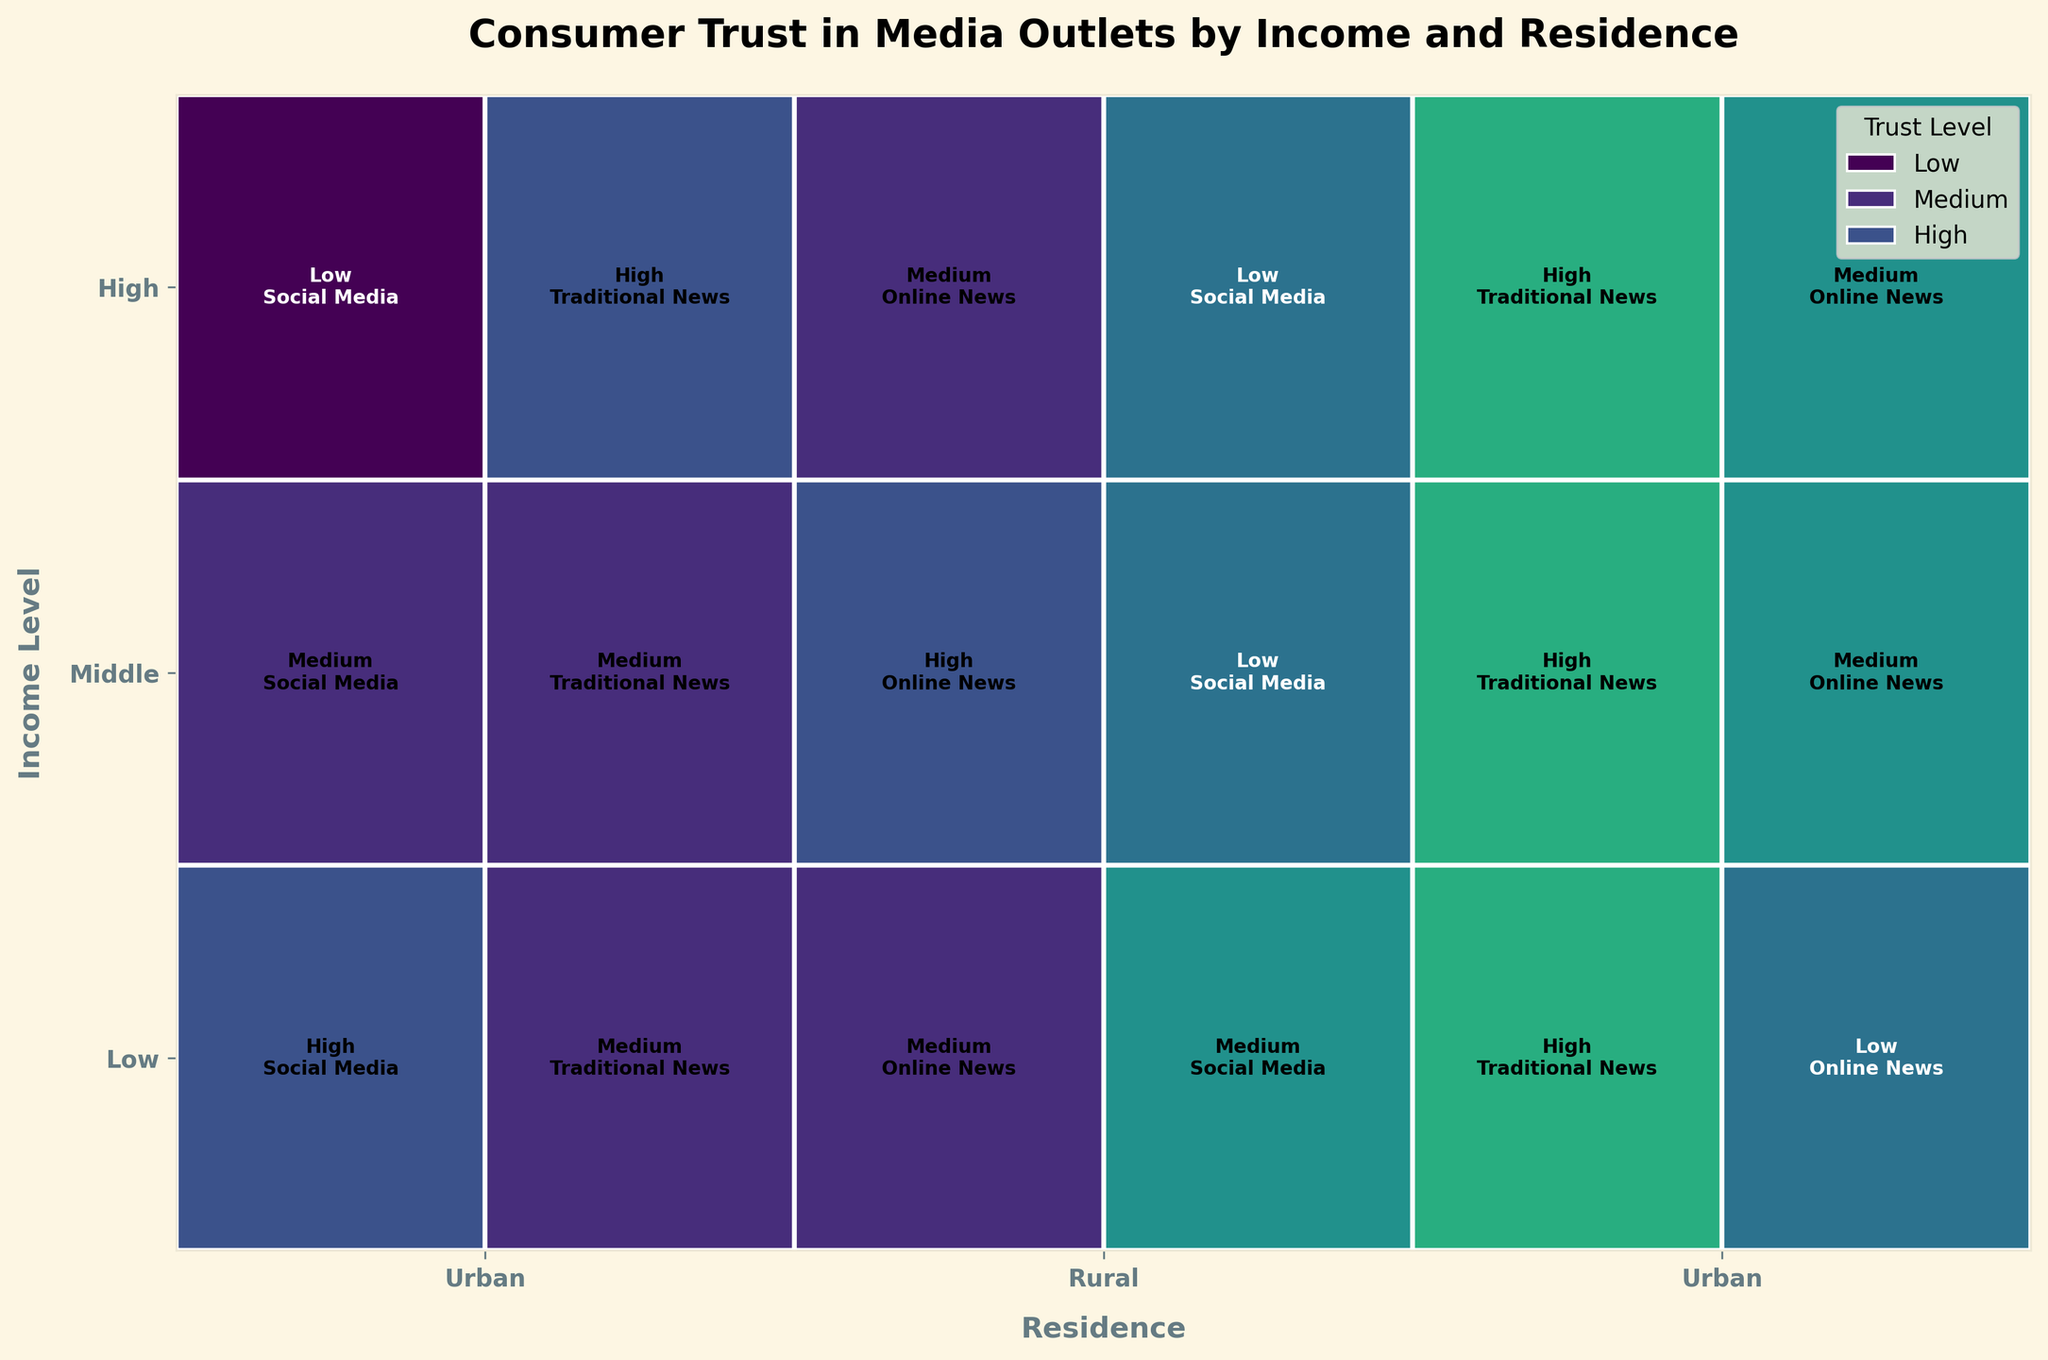What is the title of the figure? The title of the figure is usually found at the top center of most plots. In this figure, it reads “Consumer Trust in Media Outlets by Income and Residence”.
Answer: Consumer Trust in Media Outlets by Income and Residence What are the Income Levels represented in the figure? The Income Levels are shown on the y-axis and specified as "Low", "Middle", and "High".
Answer: Low, Middle, High Which trust level has the most representations for Traditional News in Rural areas? Observing the rectangles corresponding to Traditional News in Rural areas, they are colored similarly. Most of these rectangles have the same color representing "High" trust level.
Answer: High What is the trust level of Online News in Middle-income Urban areas? By following the legend and the color coding, the rectangle for Online News in Middle-income Urban areas falls in the "High" trust level category.
Answer: High Compare the trust levels in Social Media between Low-income Urban and Rural areas. Which is higher? By observing the colors of the rectangles, Low-income Urban has "High" trust level, whereas Low-income Rural has "Medium" trust level. The color for "High" (Urban) is distinct from "Medium" (Rural).
Answer: Urban Which income level has the largest rectangle area in the plot? The area of each rectangle is proportional to the income level proportion. The largest rectangles appear in the "Low" income level, as it occupies the most space on the y-axis.
Answer: Low What is the trust level of Traditional News in High-income Urban areas? From the colors and the respective media category in the Urban section under the High-income level, it is marked as "High".
Answer: High For Middle-income levels, which residence type has higher trust in Social Media? By comparing the color coding of Social Media for Urban and Rural Middle-income levels, Urban is marked as "Medium" while Rural is "Low", making Urban have a higher trust level.
Answer: Urban Which media type has the highest trust level for Low-income Rural residents? By observing the color coding and labels in the Low-income Rural segment, Traditional News shows "High" trust while Online News and Social Media are lower.
Answer: Traditional News Identify the media type and trust level with the highest trust in the entire plot. The plot shows "High" trust levels in yellow color, and they are most widespread in Traditional News both in urban and rural areas across all income levels.
Answer: Traditional News, High 